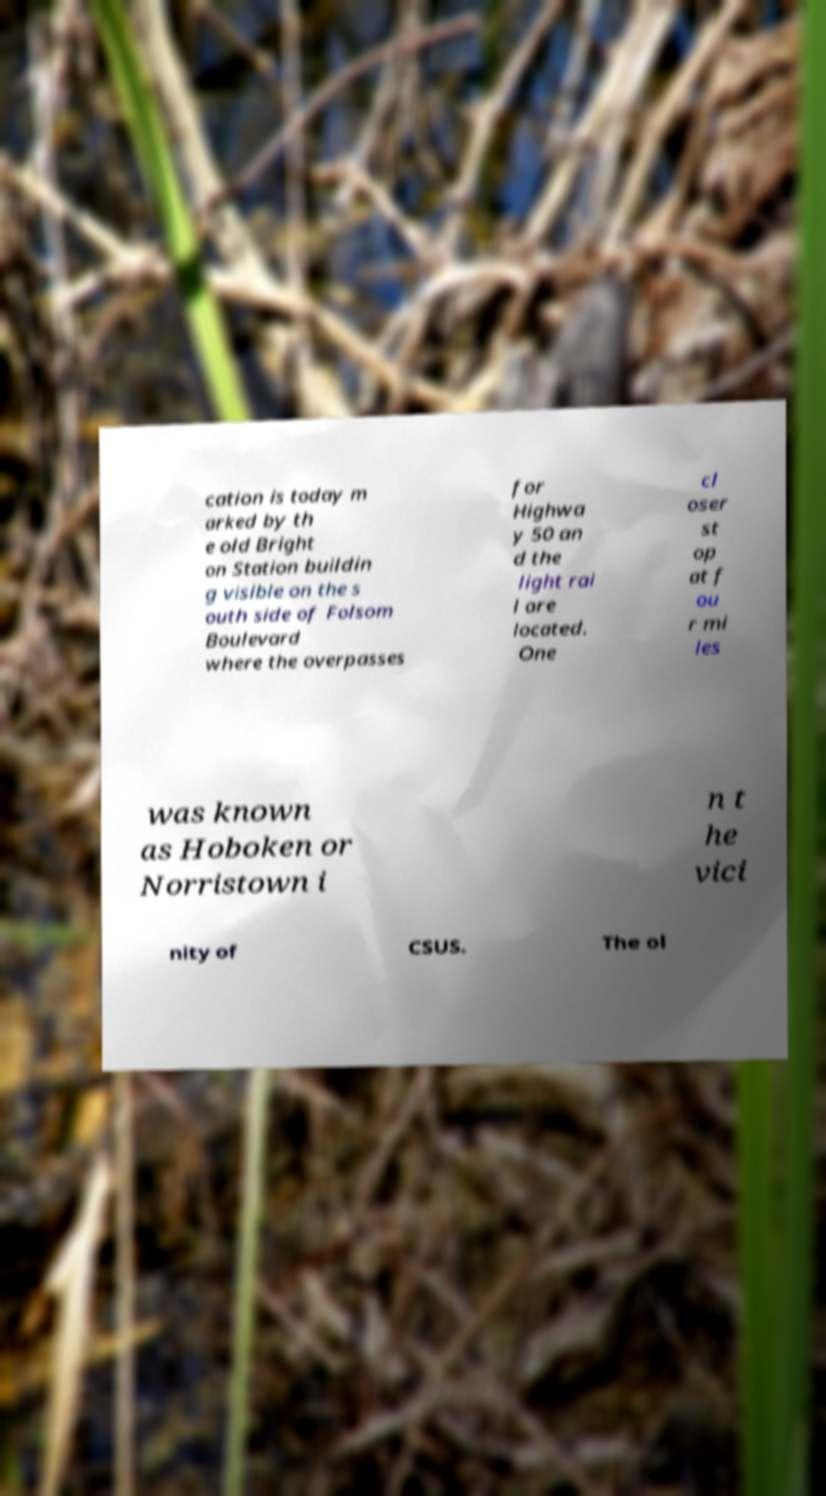What messages or text are displayed in this image? I need them in a readable, typed format. cation is today m arked by th e old Bright on Station buildin g visible on the s outh side of Folsom Boulevard where the overpasses for Highwa y 50 an d the light rai l are located. One cl oser st op at f ou r mi les was known as Hoboken or Norristown i n t he vici nity of CSUS. The ol 